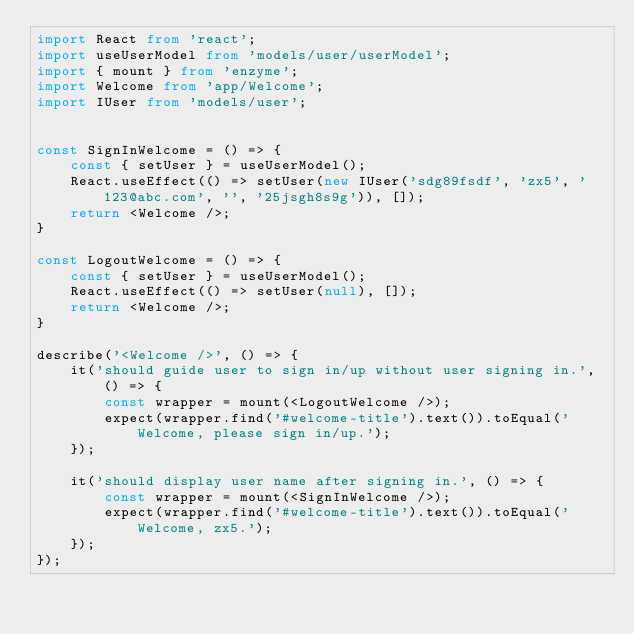Convert code to text. <code><loc_0><loc_0><loc_500><loc_500><_TypeScript_>import React from 'react';
import useUserModel from 'models/user/userModel';
import { mount } from 'enzyme';
import Welcome from 'app/Welcome';
import IUser from 'models/user';


const SignInWelcome = () => {
    const { setUser } = useUserModel();
    React.useEffect(() => setUser(new IUser('sdg89fsdf', 'zx5', '123@abc.com', '', '25jsgh8s9g')), []);
    return <Welcome />;
}

const LogoutWelcome = () => {
    const { setUser } = useUserModel();
    React.useEffect(() => setUser(null), []);
    return <Welcome />;
}

describe('<Welcome />', () => {
    it('should guide user to sign in/up without user signing in.', () => {
        const wrapper = mount(<LogoutWelcome />);
        expect(wrapper.find('#welcome-title').text()).toEqual('Welcome, please sign in/up.');
    });

    it('should display user name after signing in.', () => {
        const wrapper = mount(<SignInWelcome />);
        expect(wrapper.find('#welcome-title').text()).toEqual('Welcome, zx5.');
    });
});
</code> 